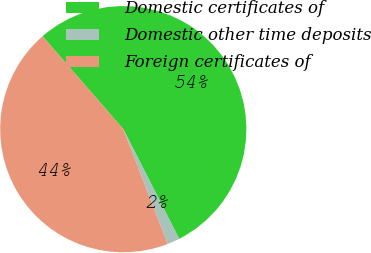Convert chart. <chart><loc_0><loc_0><loc_500><loc_500><pie_chart><fcel>Domestic certificates of<fcel>Domestic other time deposits<fcel>Foreign certificates of<nl><fcel>53.89%<fcel>1.62%<fcel>44.49%<nl></chart> 